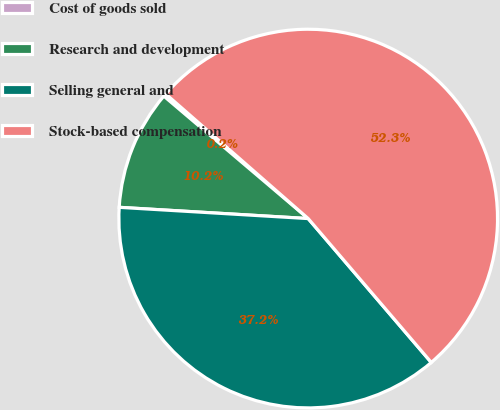Convert chart. <chart><loc_0><loc_0><loc_500><loc_500><pie_chart><fcel>Cost of goods sold<fcel>Research and development<fcel>Selling general and<fcel>Stock-based compensation<nl><fcel>0.24%<fcel>10.25%<fcel>37.21%<fcel>52.3%<nl></chart> 